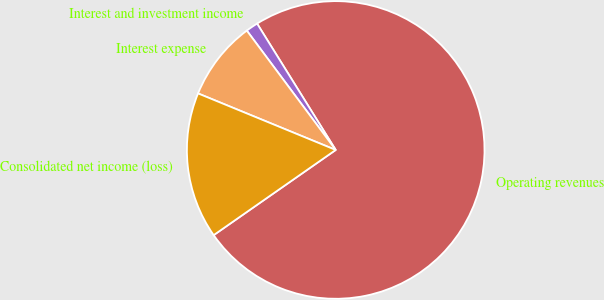<chart> <loc_0><loc_0><loc_500><loc_500><pie_chart><fcel>Operating revenues<fcel>Interest and investment income<fcel>Interest expense<fcel>Consolidated net income (loss)<nl><fcel>74.16%<fcel>1.33%<fcel>8.61%<fcel>15.9%<nl></chart> 